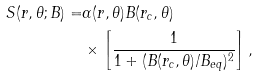Convert formula to latex. <formula><loc_0><loc_0><loc_500><loc_500>S ( r , \theta ; B ) = & \alpha ( r , \theta ) B ( r _ { c } , \theta ) \\ & \times \left [ \frac { 1 } { 1 + ( B ( r _ { c } , \theta ) / B _ { e q } ) ^ { 2 } } \right ] ,</formula> 